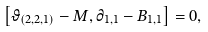Convert formula to latex. <formula><loc_0><loc_0><loc_500><loc_500>\left [ \vartheta _ { ( 2 , 2 , 1 ) } - M , \partial _ { 1 , 1 } - B _ { 1 , 1 } \right ] = 0 ,</formula> 